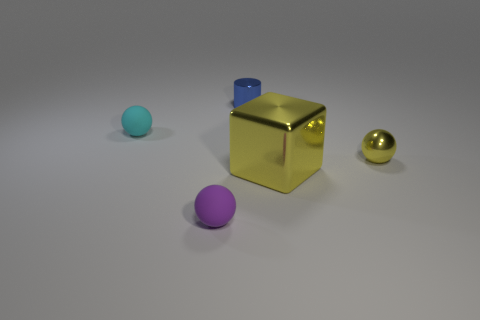What number of other objects are the same color as the block?
Offer a terse response. 1. There is a large thing; is its color the same as the small metal thing to the right of the blue cylinder?
Make the answer very short. Yes. Is there anything else that is the same size as the yellow block?
Your answer should be very brief. No. Are there any other things that have the same shape as the small blue metallic thing?
Provide a succinct answer. No. The yellow metallic thing that is the same shape as the cyan rubber object is what size?
Ensure brevity in your answer.  Small. Does the rubber ball behind the metallic cube have the same size as the big yellow metal block?
Offer a terse response. No. There is a sphere that is in front of the tiny cyan rubber object and left of the tiny blue shiny cylinder; how big is it?
Keep it short and to the point. Small. There is a tiny thing that is the same color as the big shiny object; what is its material?
Provide a short and direct response. Metal. What number of small balls have the same color as the shiny cylinder?
Your answer should be compact. 0. Are there an equal number of yellow metallic blocks behind the yellow cube and tiny cyan balls?
Give a very brief answer. No. 